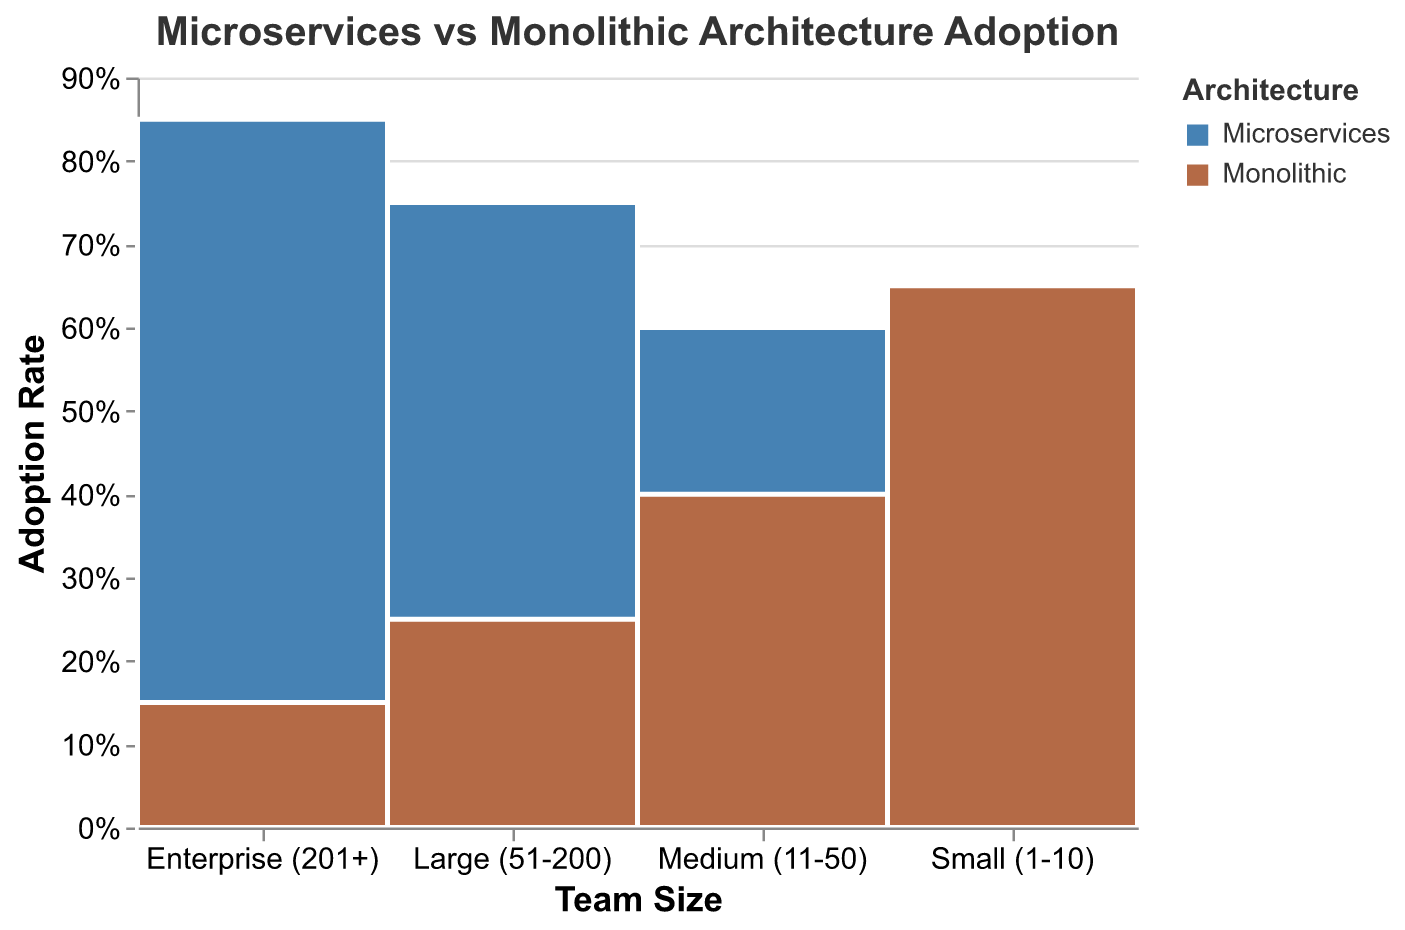What is the title of the chart? The title of the chart is displayed at the top center. It reads "Microservices vs Monolithic Architecture Adoption."
Answer: Microservices vs Monolithic Architecture Adoption Which architecture has a higher adoption rate for small teams (1-10 members)? Locate the "Small (1-10)" category on the X-axis and compare the heights of the two segments. The Microservices segment is lower than the Monolithic segment.
Answer: Monolithic What is the adoption rate percentage for Microservices among enterprise teams (201+)? Hover over the "Enterprise (201+)" category on the X-axis and read the percentage from the tooltip or visually estimate it using the Y-axis.
Answer: 85% What is the overall trend in adoption rate for Microservices as team size increases? Observe the Microservices segments across different team sizes. The height increases progressively from "Small (1-10)" to "Enterprise (201+)."
Answer: Increases Which team size category shows the largest difference in adoption rates between Microservices and Monolithic architectures? Compare the height differences in each team size category by visually inspecting the segments. The largest difference is in the "Enterprise (201+)" category.
Answer: Enterprise (201+) How does the adoption rate of Monolithic architecture compare to Microservices for medium teams (11-50)? Look for the "Medium (11-50)" category on the X-axis and compare the heights of the Monolithic and Microservices segments. The Monolithic segment is shorter than the Microservices segment.
Answer: Less For which team sizes is Microservices adoption less than 50%? Identify the Microservices segments with heights corresponding to less than 50% on the Y-axis. The "Small (1-10)" team size falls within this range.
Answer: Small (1-10) What can be inferred about the adoption of Monolithic architecture in large teams (51-200)? Observe the height of the Monolithic segment in the "Large (51-200)" category. The adoption rate is quite low, indicating it is not preferred in large teams.
Answer: Low adoption Is there any team size category where both architectures have equal adoption rates? Check each team size category and compare the heights of the segments. No categories have equal heights for both architectures.
Answer: No What general pattern can be observed about architecture adoption and team size? Examine the segments across all team sizes. Microservices adoption increases with team size, while Monolithic adoption decreases.
Answer: Microservices increase, Monolithic decrease 